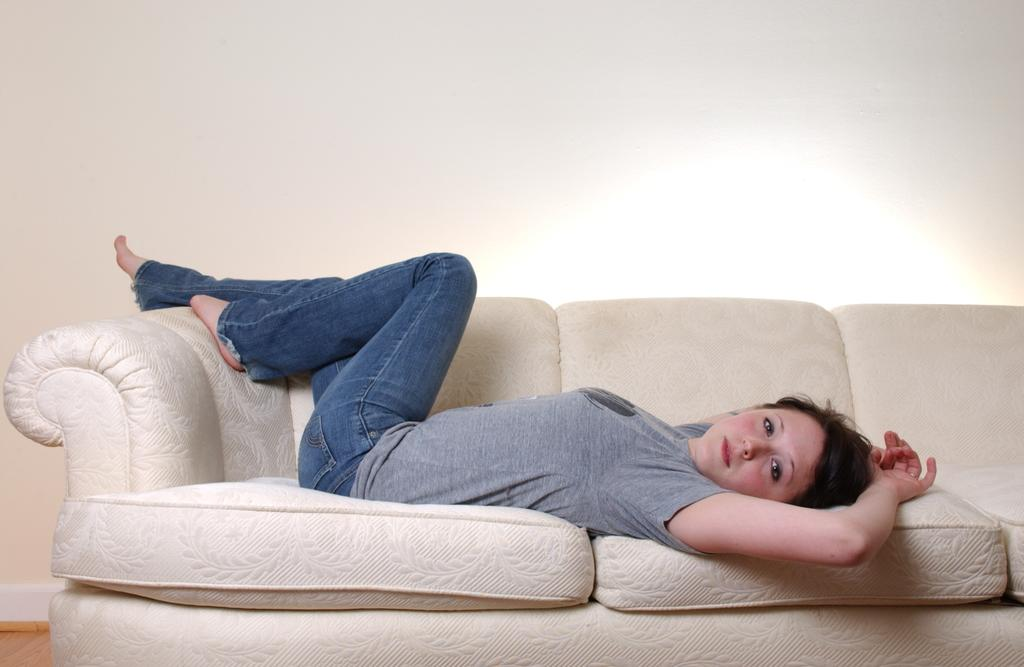Who is the main subject in the image? There is a woman in the image. What is the woman doing in the image? The woman is laying on a cream color couch. What can be seen in the background of the image? There is a wall in the background of the image. What grade did the stranger give the woman in the image? There is no stranger present in the image, and therefore no grade can be given. 